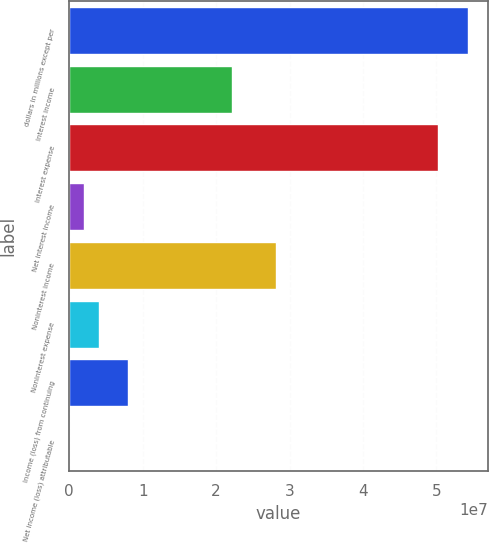<chart> <loc_0><loc_0><loc_500><loc_500><bar_chart><fcel>dollars in millions except per<fcel>Interest income<fcel>Interest expense<fcel>Net interest income<fcel>Noninterest income<fcel>Noninterest expense<fcel>Income (loss) from continuing<fcel>Net income (loss) attributable<nl><fcel>5.43024e+07<fcel>2.21232e+07<fcel>5.028e+07<fcel>2.0112e+06<fcel>2.81568e+07<fcel>4.0224e+06<fcel>8.04481e+06<fcel>0.1<nl></chart> 